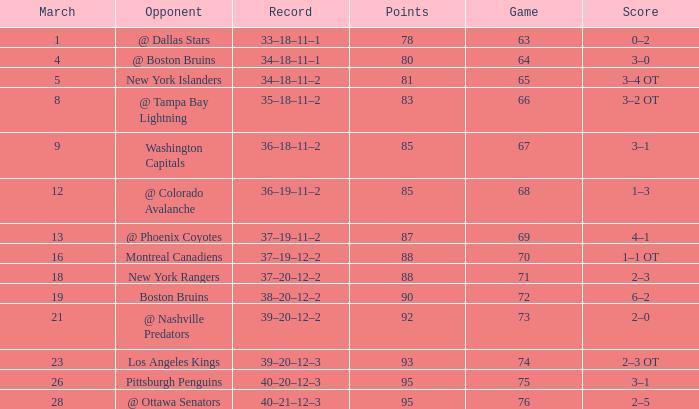I'm looking to parse the entire table for insights. Could you assist me with that? {'header': ['March', 'Opponent', 'Record', 'Points', 'Game', 'Score'], 'rows': [['1', '@ Dallas Stars', '33–18–11–1', '78', '63', '0–2'], ['4', '@ Boston Bruins', '34–18–11–1', '80', '64', '3–0'], ['5', 'New York Islanders', '34–18–11–2', '81', '65', '3–4 OT'], ['8', '@ Tampa Bay Lightning', '35–18–11–2', '83', '66', '3–2 OT'], ['9', 'Washington Capitals', '36–18–11–2', '85', '67', '3–1'], ['12', '@ Colorado Avalanche', '36–19–11–2', '85', '68', '1–3'], ['13', '@ Phoenix Coyotes', '37–19–11–2', '87', '69', '4–1'], ['16', 'Montreal Canadiens', '37–19–12–2', '88', '70', '1–1 OT'], ['18', 'New York Rangers', '37–20–12–2', '88', '71', '2–3'], ['19', 'Boston Bruins', '38–20–12–2', '90', '72', '6–2'], ['21', '@ Nashville Predators', '39–20–12–2', '92', '73', '2–0'], ['23', 'Los Angeles Kings', '39–20–12–3', '93', '74', '2–3 OT'], ['26', 'Pittsburgh Penguins', '40–20–12–3', '95', '75', '3–1'], ['28', '@ Ottawa Senators', '40–21–12–3', '95', '76', '2–5']]} How many Points have a Record of 40–21–12–3, and a March larger than 28? 0.0. 